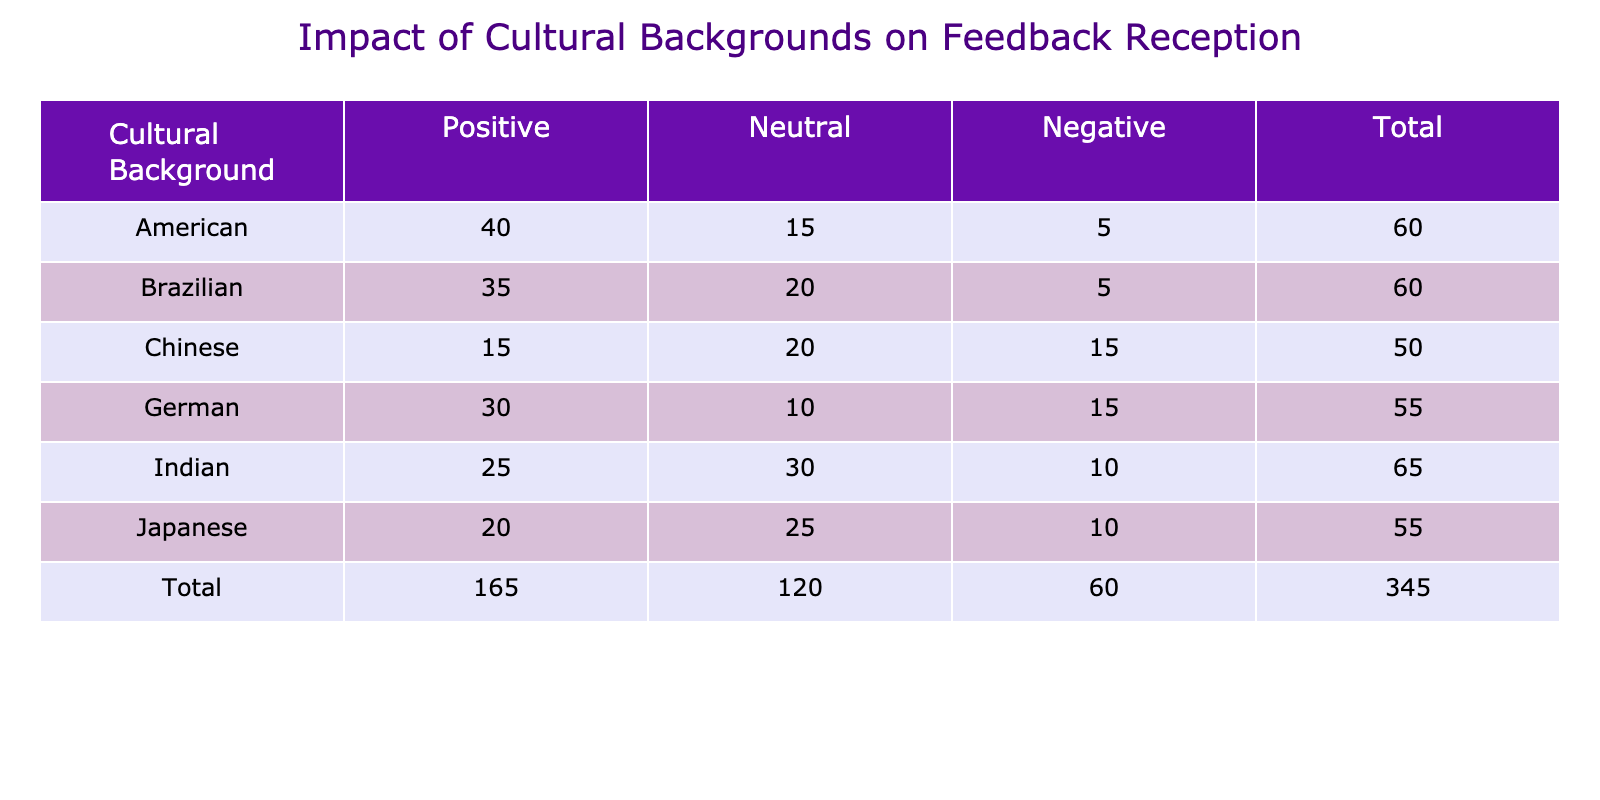What is the highest count of positive feedback for any cultural background? The highest count of positive feedback can be found by looking at the 'Positive' column in the table. The counts are: American (40), Japanese (20), German (30), Chinese (15), Indian (25), and Brazilian (35). The maximum among these is 40 from the American background.
Answer: 40 What is the total number of responses from Indian employees? To find the total responses from Indian employees, we need to sum the values in all categories applicable to Indian: Positive (25), Neutral (30), and Negative (10). The total is calculated as 25 + 30 + 10 = 65.
Answer: 65 Is the number of neutral responses higher for Americans than for Germans? To answer this, we need to compare the 'Neutral' responses in the table. Americans have a Neutral count of 15, while Germans have a Neutral count of 10. Since 15 is greater than 10, the statement is true.
Answer: Yes What is the average number of negative feedback responses across all cultural backgrounds? To calculate the average, we first find the total number of negative responses from each background: American (5), Japanese (10), German (15), Chinese (15), Indian (10), Brazilian (5). The total is 5 + 10 + 15 + 15 + 10 + 5 = 60. There are 6 backgrounds, so the average is 60 / 6 = 10.
Answer: 10 Which cultural background has the lowest total feedback count? First, we calculate the total feedback for each cultural background: American (40 + 15 + 5 = 60), Japanese (20 + 25 + 10 = 55), German (30 + 10 + 15 = 55), Chinese (15 + 20 + 15 = 50), Indian (25 + 30 + 10 = 65), Brazilian (35 + 20 + 5 = 60). The lowest total is 50 for the Chinese background.
Answer: Chinese 